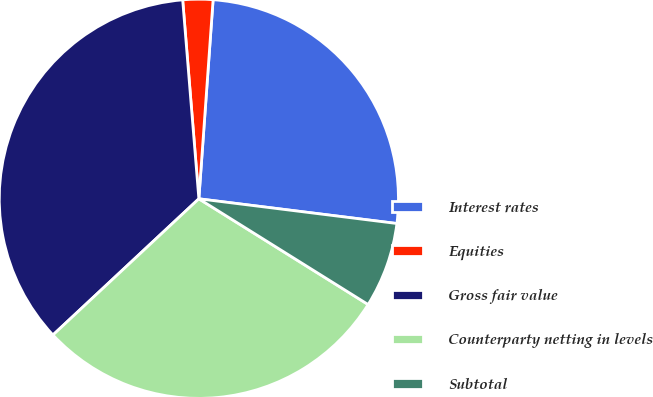Convert chart to OTSL. <chart><loc_0><loc_0><loc_500><loc_500><pie_chart><fcel>Interest rates<fcel>Equities<fcel>Gross fair value<fcel>Counterparty netting in levels<fcel>Subtotal<nl><fcel>25.84%<fcel>2.43%<fcel>35.66%<fcel>29.16%<fcel>6.91%<nl></chart> 